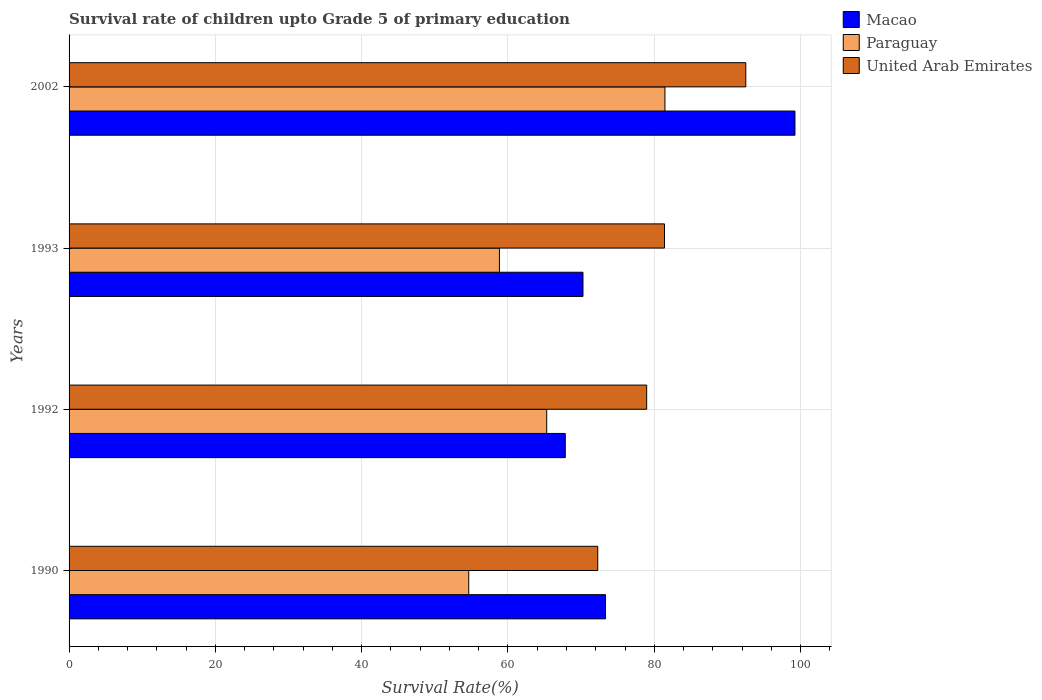How many different coloured bars are there?
Your response must be concise. 3. How many groups of bars are there?
Provide a succinct answer. 4. How many bars are there on the 4th tick from the bottom?
Make the answer very short. 3. In how many cases, is the number of bars for a given year not equal to the number of legend labels?
Provide a succinct answer. 0. What is the survival rate of children in Macao in 1990?
Offer a terse response. 73.33. Across all years, what is the maximum survival rate of children in Macao?
Keep it short and to the point. 99.23. Across all years, what is the minimum survival rate of children in United Arab Emirates?
Your answer should be compact. 72.27. In which year was the survival rate of children in Macao maximum?
Your response must be concise. 2002. In which year was the survival rate of children in Paraguay minimum?
Keep it short and to the point. 1990. What is the total survival rate of children in Paraguay in the graph?
Ensure brevity in your answer.  260.21. What is the difference between the survival rate of children in Paraguay in 1993 and that in 2002?
Give a very brief answer. -22.63. What is the difference between the survival rate of children in Paraguay in 1992 and the survival rate of children in Macao in 2002?
Make the answer very short. -33.94. What is the average survival rate of children in Paraguay per year?
Ensure brevity in your answer.  65.05. In the year 1992, what is the difference between the survival rate of children in Macao and survival rate of children in United Arab Emirates?
Give a very brief answer. -11.13. What is the ratio of the survival rate of children in Paraguay in 1992 to that in 2002?
Ensure brevity in your answer.  0.8. Is the survival rate of children in Paraguay in 1992 less than that in 1993?
Make the answer very short. No. What is the difference between the highest and the second highest survival rate of children in Paraguay?
Your answer should be compact. 16.16. What is the difference between the highest and the lowest survival rate of children in Paraguay?
Ensure brevity in your answer.  26.82. In how many years, is the survival rate of children in United Arab Emirates greater than the average survival rate of children in United Arab Emirates taken over all years?
Offer a very short reply. 2. Is the sum of the survival rate of children in Paraguay in 1992 and 1993 greater than the maximum survival rate of children in United Arab Emirates across all years?
Make the answer very short. Yes. What does the 2nd bar from the top in 1990 represents?
Your response must be concise. Paraguay. What does the 3rd bar from the bottom in 1993 represents?
Offer a terse response. United Arab Emirates. Is it the case that in every year, the sum of the survival rate of children in Paraguay and survival rate of children in Macao is greater than the survival rate of children in United Arab Emirates?
Ensure brevity in your answer.  Yes. How many years are there in the graph?
Your answer should be compact. 4. How many legend labels are there?
Provide a succinct answer. 3. How are the legend labels stacked?
Keep it short and to the point. Vertical. What is the title of the graph?
Your answer should be very brief. Survival rate of children upto Grade 5 of primary education. What is the label or title of the X-axis?
Keep it short and to the point. Survival Rate(%). What is the Survival Rate(%) of Macao in 1990?
Provide a short and direct response. 73.33. What is the Survival Rate(%) in Paraguay in 1990?
Your answer should be very brief. 54.63. What is the Survival Rate(%) of United Arab Emirates in 1990?
Keep it short and to the point. 72.27. What is the Survival Rate(%) in Macao in 1992?
Your answer should be very brief. 67.83. What is the Survival Rate(%) in Paraguay in 1992?
Your answer should be compact. 65.29. What is the Survival Rate(%) of United Arab Emirates in 1992?
Your answer should be compact. 78.96. What is the Survival Rate(%) of Macao in 1993?
Provide a short and direct response. 70.25. What is the Survival Rate(%) in Paraguay in 1993?
Keep it short and to the point. 58.83. What is the Survival Rate(%) of United Arab Emirates in 1993?
Offer a terse response. 81.39. What is the Survival Rate(%) in Macao in 2002?
Ensure brevity in your answer.  99.23. What is the Survival Rate(%) in Paraguay in 2002?
Ensure brevity in your answer.  81.46. What is the Survival Rate(%) of United Arab Emirates in 2002?
Provide a short and direct response. 92.51. Across all years, what is the maximum Survival Rate(%) of Macao?
Give a very brief answer. 99.23. Across all years, what is the maximum Survival Rate(%) in Paraguay?
Offer a very short reply. 81.46. Across all years, what is the maximum Survival Rate(%) in United Arab Emirates?
Your answer should be very brief. 92.51. Across all years, what is the minimum Survival Rate(%) of Macao?
Your answer should be very brief. 67.83. Across all years, what is the minimum Survival Rate(%) in Paraguay?
Your answer should be compact. 54.63. Across all years, what is the minimum Survival Rate(%) of United Arab Emirates?
Offer a terse response. 72.27. What is the total Survival Rate(%) of Macao in the graph?
Your answer should be compact. 310.65. What is the total Survival Rate(%) in Paraguay in the graph?
Give a very brief answer. 260.21. What is the total Survival Rate(%) of United Arab Emirates in the graph?
Keep it short and to the point. 325.13. What is the difference between the Survival Rate(%) of Macao in 1990 and that in 1992?
Provide a succinct answer. 5.5. What is the difference between the Survival Rate(%) of Paraguay in 1990 and that in 1992?
Provide a short and direct response. -10.66. What is the difference between the Survival Rate(%) in United Arab Emirates in 1990 and that in 1992?
Provide a succinct answer. -6.69. What is the difference between the Survival Rate(%) of Macao in 1990 and that in 1993?
Make the answer very short. 3.08. What is the difference between the Survival Rate(%) of Paraguay in 1990 and that in 1993?
Offer a terse response. -4.19. What is the difference between the Survival Rate(%) in United Arab Emirates in 1990 and that in 1993?
Offer a very short reply. -9.12. What is the difference between the Survival Rate(%) of Macao in 1990 and that in 2002?
Offer a terse response. -25.9. What is the difference between the Survival Rate(%) in Paraguay in 1990 and that in 2002?
Give a very brief answer. -26.82. What is the difference between the Survival Rate(%) of United Arab Emirates in 1990 and that in 2002?
Your answer should be very brief. -20.24. What is the difference between the Survival Rate(%) of Macao in 1992 and that in 1993?
Give a very brief answer. -2.42. What is the difference between the Survival Rate(%) in Paraguay in 1992 and that in 1993?
Offer a terse response. 6.46. What is the difference between the Survival Rate(%) of United Arab Emirates in 1992 and that in 1993?
Provide a succinct answer. -2.43. What is the difference between the Survival Rate(%) of Macao in 1992 and that in 2002?
Keep it short and to the point. -31.39. What is the difference between the Survival Rate(%) of Paraguay in 1992 and that in 2002?
Give a very brief answer. -16.16. What is the difference between the Survival Rate(%) of United Arab Emirates in 1992 and that in 2002?
Your answer should be compact. -13.55. What is the difference between the Survival Rate(%) in Macao in 1993 and that in 2002?
Your response must be concise. -28.98. What is the difference between the Survival Rate(%) in Paraguay in 1993 and that in 2002?
Provide a short and direct response. -22.63. What is the difference between the Survival Rate(%) in United Arab Emirates in 1993 and that in 2002?
Make the answer very short. -11.11. What is the difference between the Survival Rate(%) in Macao in 1990 and the Survival Rate(%) in Paraguay in 1992?
Provide a succinct answer. 8.04. What is the difference between the Survival Rate(%) of Macao in 1990 and the Survival Rate(%) of United Arab Emirates in 1992?
Give a very brief answer. -5.63. What is the difference between the Survival Rate(%) of Paraguay in 1990 and the Survival Rate(%) of United Arab Emirates in 1992?
Offer a terse response. -24.33. What is the difference between the Survival Rate(%) in Macao in 1990 and the Survival Rate(%) in Paraguay in 1993?
Offer a terse response. 14.5. What is the difference between the Survival Rate(%) of Macao in 1990 and the Survival Rate(%) of United Arab Emirates in 1993?
Provide a succinct answer. -8.06. What is the difference between the Survival Rate(%) of Paraguay in 1990 and the Survival Rate(%) of United Arab Emirates in 1993?
Provide a succinct answer. -26.76. What is the difference between the Survival Rate(%) in Macao in 1990 and the Survival Rate(%) in Paraguay in 2002?
Offer a terse response. -8.12. What is the difference between the Survival Rate(%) in Macao in 1990 and the Survival Rate(%) in United Arab Emirates in 2002?
Your answer should be very brief. -19.17. What is the difference between the Survival Rate(%) in Paraguay in 1990 and the Survival Rate(%) in United Arab Emirates in 2002?
Ensure brevity in your answer.  -37.87. What is the difference between the Survival Rate(%) in Macao in 1992 and the Survival Rate(%) in Paraguay in 1993?
Offer a very short reply. 9. What is the difference between the Survival Rate(%) in Macao in 1992 and the Survival Rate(%) in United Arab Emirates in 1993?
Offer a terse response. -13.56. What is the difference between the Survival Rate(%) of Paraguay in 1992 and the Survival Rate(%) of United Arab Emirates in 1993?
Keep it short and to the point. -16.1. What is the difference between the Survival Rate(%) in Macao in 1992 and the Survival Rate(%) in Paraguay in 2002?
Give a very brief answer. -13.62. What is the difference between the Survival Rate(%) in Macao in 1992 and the Survival Rate(%) in United Arab Emirates in 2002?
Provide a succinct answer. -24.67. What is the difference between the Survival Rate(%) in Paraguay in 1992 and the Survival Rate(%) in United Arab Emirates in 2002?
Make the answer very short. -27.21. What is the difference between the Survival Rate(%) of Macao in 1993 and the Survival Rate(%) of Paraguay in 2002?
Ensure brevity in your answer.  -11.2. What is the difference between the Survival Rate(%) of Macao in 1993 and the Survival Rate(%) of United Arab Emirates in 2002?
Offer a very short reply. -22.25. What is the difference between the Survival Rate(%) in Paraguay in 1993 and the Survival Rate(%) in United Arab Emirates in 2002?
Make the answer very short. -33.68. What is the average Survival Rate(%) in Macao per year?
Provide a succinct answer. 77.66. What is the average Survival Rate(%) of Paraguay per year?
Keep it short and to the point. 65.05. What is the average Survival Rate(%) of United Arab Emirates per year?
Provide a short and direct response. 81.28. In the year 1990, what is the difference between the Survival Rate(%) of Macao and Survival Rate(%) of Paraguay?
Offer a very short reply. 18.7. In the year 1990, what is the difference between the Survival Rate(%) of Macao and Survival Rate(%) of United Arab Emirates?
Make the answer very short. 1.06. In the year 1990, what is the difference between the Survival Rate(%) of Paraguay and Survival Rate(%) of United Arab Emirates?
Provide a short and direct response. -17.64. In the year 1992, what is the difference between the Survival Rate(%) in Macao and Survival Rate(%) in Paraguay?
Give a very brief answer. 2.54. In the year 1992, what is the difference between the Survival Rate(%) of Macao and Survival Rate(%) of United Arab Emirates?
Offer a terse response. -11.13. In the year 1992, what is the difference between the Survival Rate(%) of Paraguay and Survival Rate(%) of United Arab Emirates?
Provide a succinct answer. -13.67. In the year 1993, what is the difference between the Survival Rate(%) in Macao and Survival Rate(%) in Paraguay?
Your answer should be compact. 11.42. In the year 1993, what is the difference between the Survival Rate(%) of Macao and Survival Rate(%) of United Arab Emirates?
Make the answer very short. -11.14. In the year 1993, what is the difference between the Survival Rate(%) in Paraguay and Survival Rate(%) in United Arab Emirates?
Your answer should be very brief. -22.56. In the year 2002, what is the difference between the Survival Rate(%) in Macao and Survival Rate(%) in Paraguay?
Your answer should be compact. 17.77. In the year 2002, what is the difference between the Survival Rate(%) of Macao and Survival Rate(%) of United Arab Emirates?
Your response must be concise. 6.72. In the year 2002, what is the difference between the Survival Rate(%) in Paraguay and Survival Rate(%) in United Arab Emirates?
Offer a terse response. -11.05. What is the ratio of the Survival Rate(%) in Macao in 1990 to that in 1992?
Offer a terse response. 1.08. What is the ratio of the Survival Rate(%) in Paraguay in 1990 to that in 1992?
Your response must be concise. 0.84. What is the ratio of the Survival Rate(%) of United Arab Emirates in 1990 to that in 1992?
Give a very brief answer. 0.92. What is the ratio of the Survival Rate(%) in Macao in 1990 to that in 1993?
Provide a succinct answer. 1.04. What is the ratio of the Survival Rate(%) of Paraguay in 1990 to that in 1993?
Provide a short and direct response. 0.93. What is the ratio of the Survival Rate(%) in United Arab Emirates in 1990 to that in 1993?
Provide a succinct answer. 0.89. What is the ratio of the Survival Rate(%) in Macao in 1990 to that in 2002?
Provide a short and direct response. 0.74. What is the ratio of the Survival Rate(%) of Paraguay in 1990 to that in 2002?
Keep it short and to the point. 0.67. What is the ratio of the Survival Rate(%) of United Arab Emirates in 1990 to that in 2002?
Your response must be concise. 0.78. What is the ratio of the Survival Rate(%) in Macao in 1992 to that in 1993?
Your response must be concise. 0.97. What is the ratio of the Survival Rate(%) of Paraguay in 1992 to that in 1993?
Make the answer very short. 1.11. What is the ratio of the Survival Rate(%) of United Arab Emirates in 1992 to that in 1993?
Offer a very short reply. 0.97. What is the ratio of the Survival Rate(%) in Macao in 1992 to that in 2002?
Make the answer very short. 0.68. What is the ratio of the Survival Rate(%) of Paraguay in 1992 to that in 2002?
Keep it short and to the point. 0.8. What is the ratio of the Survival Rate(%) of United Arab Emirates in 1992 to that in 2002?
Make the answer very short. 0.85. What is the ratio of the Survival Rate(%) in Macao in 1993 to that in 2002?
Make the answer very short. 0.71. What is the ratio of the Survival Rate(%) of Paraguay in 1993 to that in 2002?
Offer a very short reply. 0.72. What is the ratio of the Survival Rate(%) of United Arab Emirates in 1993 to that in 2002?
Offer a very short reply. 0.88. What is the difference between the highest and the second highest Survival Rate(%) of Macao?
Offer a very short reply. 25.9. What is the difference between the highest and the second highest Survival Rate(%) in Paraguay?
Your answer should be very brief. 16.16. What is the difference between the highest and the second highest Survival Rate(%) in United Arab Emirates?
Give a very brief answer. 11.11. What is the difference between the highest and the lowest Survival Rate(%) in Macao?
Offer a terse response. 31.39. What is the difference between the highest and the lowest Survival Rate(%) in Paraguay?
Provide a short and direct response. 26.82. What is the difference between the highest and the lowest Survival Rate(%) of United Arab Emirates?
Ensure brevity in your answer.  20.24. 